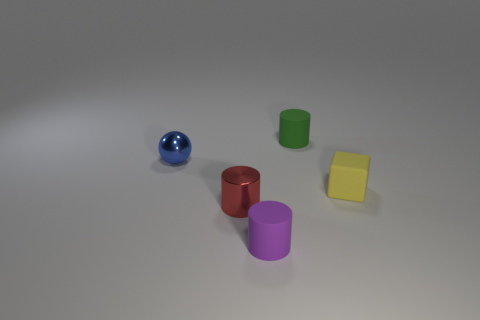Add 5 red cylinders. How many objects exist? 10 Subtract all small matte cylinders. How many cylinders are left? 1 Subtract all blocks. How many objects are left? 4 Subtract all green cylinders. How many cylinders are left? 2 Subtract 0 gray cubes. How many objects are left? 5 Subtract 1 cylinders. How many cylinders are left? 2 Subtract all cyan cylinders. Subtract all purple blocks. How many cylinders are left? 3 Subtract all cyan cubes. How many brown cylinders are left? 0 Subtract all green cylinders. Subtract all big cylinders. How many objects are left? 4 Add 2 tiny balls. How many tiny balls are left? 3 